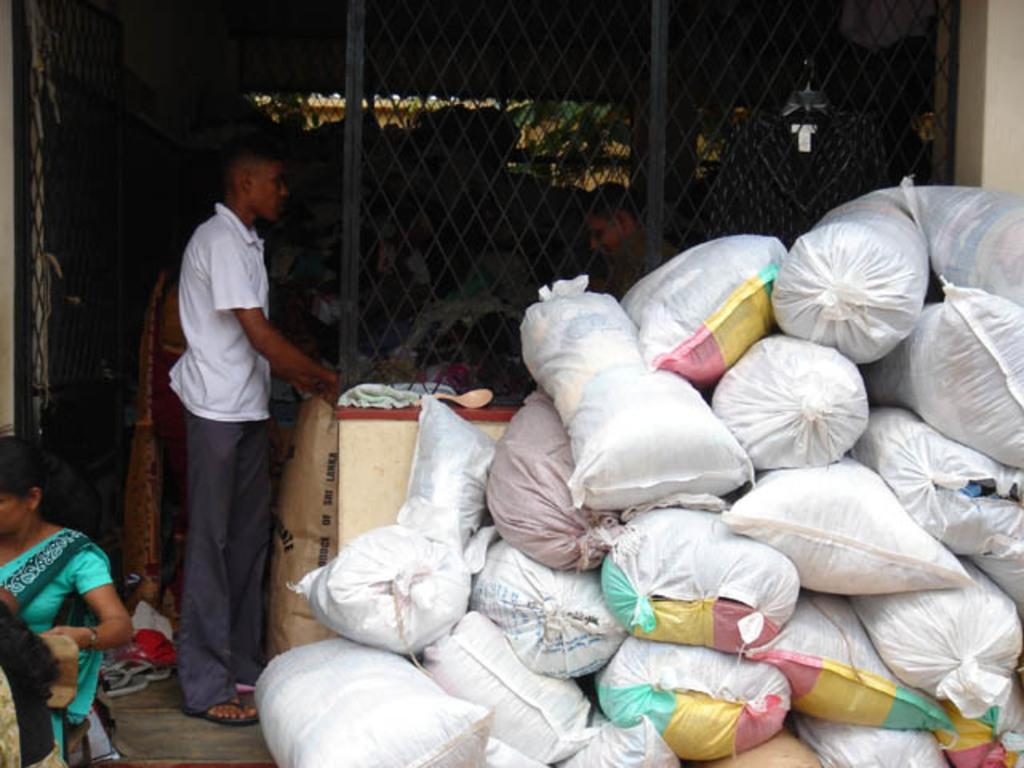Who or what can be seen in the image? There are people in the image. What are the people carrying or holding? There are bags in the image, which suggests that the people might be carrying or holding them. What is on the ground in the image? There are objects on the ground in the image. What type of barrier is present in the image? There is a black fence in the image. How would you describe the lighting or color of the background in the image? The background of the image is dark. Can you tell me how many letters the people are offering to each other in the image? There is no indication in the image that the people are offering letters to each other. Is anyone swimming in the image? There is no water or swimming activity depicted in the image. 